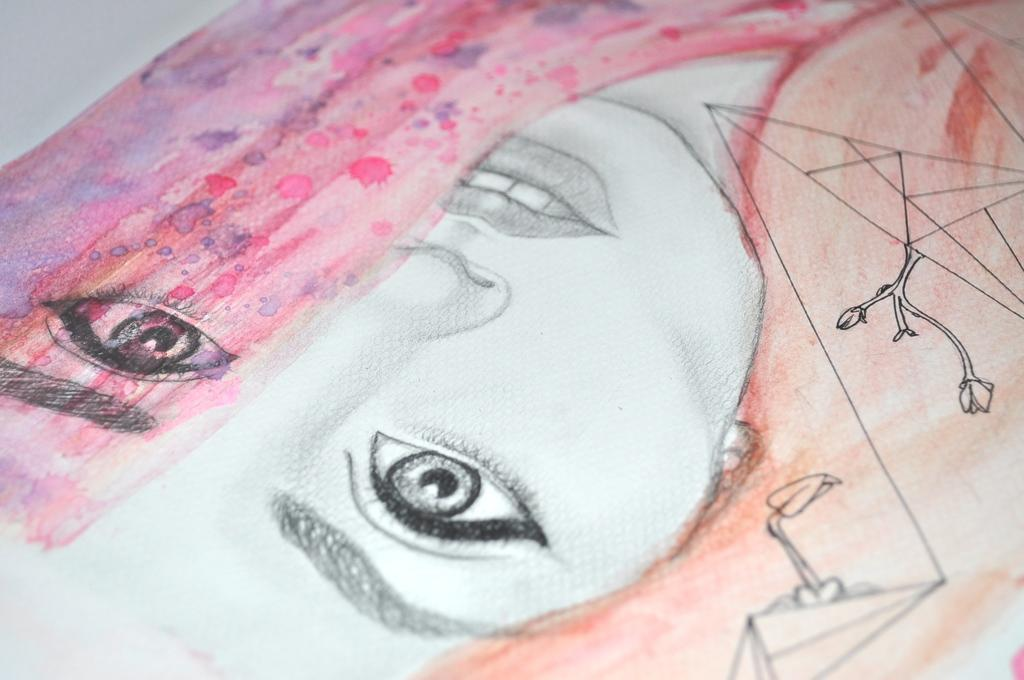What is depicted in the image? The image contains a sketch of a woman. What can be observed about the colors used in the sketch? The sketch uses different colors. What type of error can be seen in the woman's shoe in the image? There is no shoe present in the image, as it is a sketch of a woman and not a photograph or illustration of a specific scene. 